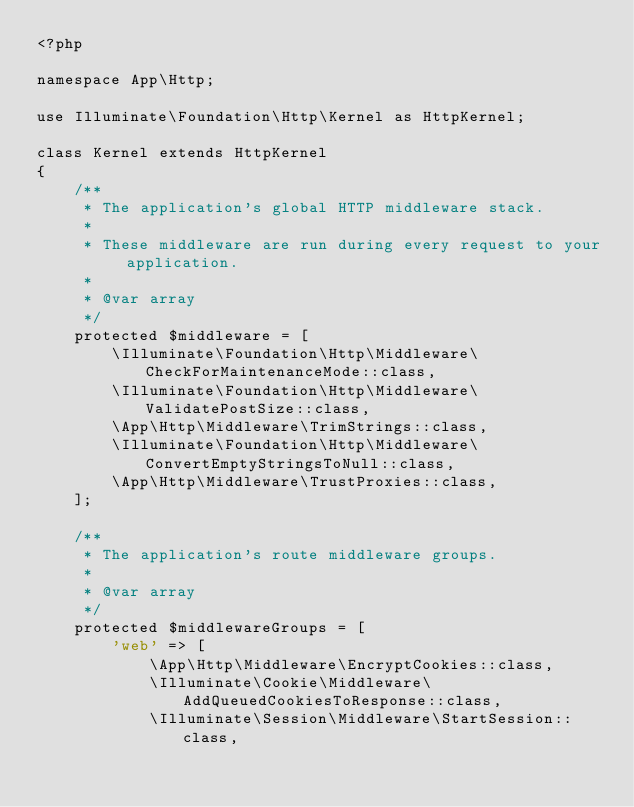Convert code to text. <code><loc_0><loc_0><loc_500><loc_500><_PHP_><?php

namespace App\Http;

use Illuminate\Foundation\Http\Kernel as HttpKernel;

class Kernel extends HttpKernel
{
    /**
     * The application's global HTTP middleware stack.
     *
     * These middleware are run during every request to your application.
     *
     * @var array
     */
    protected $middleware = [
        \Illuminate\Foundation\Http\Middleware\CheckForMaintenanceMode::class,
        \Illuminate\Foundation\Http\Middleware\ValidatePostSize::class,
        \App\Http\Middleware\TrimStrings::class,
        \Illuminate\Foundation\Http\Middleware\ConvertEmptyStringsToNull::class,
        \App\Http\Middleware\TrustProxies::class,
    ];

    /**
     * The application's route middleware groups.
     *
     * @var array
     */
    protected $middlewareGroups = [
        'web' => [
            \App\Http\Middleware\EncryptCookies::class,
            \Illuminate\Cookie\Middleware\AddQueuedCookiesToResponse::class,
            \Illuminate\Session\Middleware\StartSession::class,</code> 